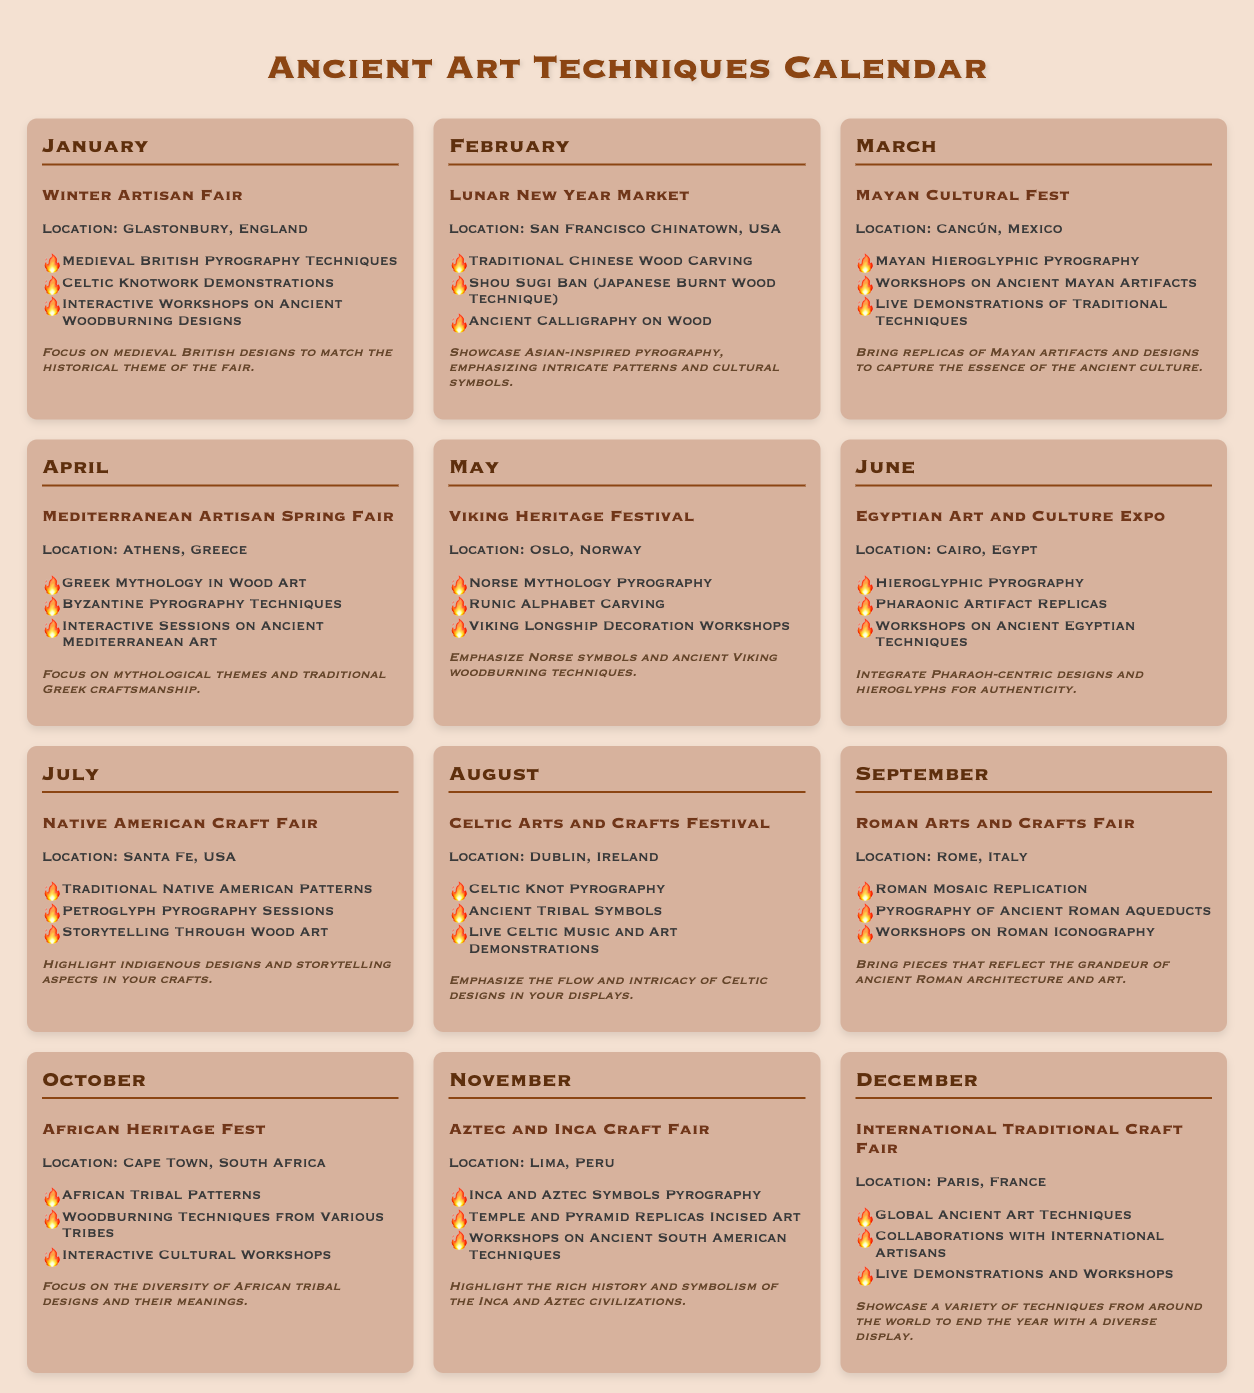What is the location of the Winter Artisan Fair? The location of the Winter Artisan Fair is mentioned in the January section of the calendar as Glastonbury, England.
Answer: Glastonbury, England Which ancient art technique is featured in the February event? February's event, the Lunar New Year Market, features Traditional Chinese Wood Carving as one of the techniques.
Answer: Traditional Chinese Wood Carving How many months showcase crafting events related to Norse culture? The Viking Heritage Festival in May is the only event dedicated to Norse culture, as indicated in the calendar.
Answer: One What type of workshops are offered during the May event? The May event, Viking Heritage Festival, includes Viking Longship Decoration Workshops.
Answer: Viking Longship Decoration Workshops What is the title of the December event? The calendar lists the December event as the International Traditional Craft Fair.
Answer: International Traditional Craft Fair Which event emphasizes storytelling in craft techniques? The Native American Craft Fair in July highlights storytelling through wood art as one of its offerings.
Answer: Native American Craft Fair How many events occur in the summer months (June, July, August)? By counting the events in these months, there are three events listed: Egyptian Art and Culture Expo, Native American Craft Fair, and Celtic Arts and Crafts Festival.
Answer: Three In which month is the Mayan Cultural Fest held? The Mayan Cultural Fest is scheduled for March as per the calendar.
Answer: March What specific cultural elements are showcased at the African Heritage Fest? The calendar mentions African Tribal Patterns and Woodburning Techniques from Various Tribes as highlights of this event.
Answer: African Tribal Patterns and Woodburning Techniques from Various Tribes 